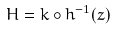<formula> <loc_0><loc_0><loc_500><loc_500>H = k \circ h ^ { - 1 } ( z )</formula> 